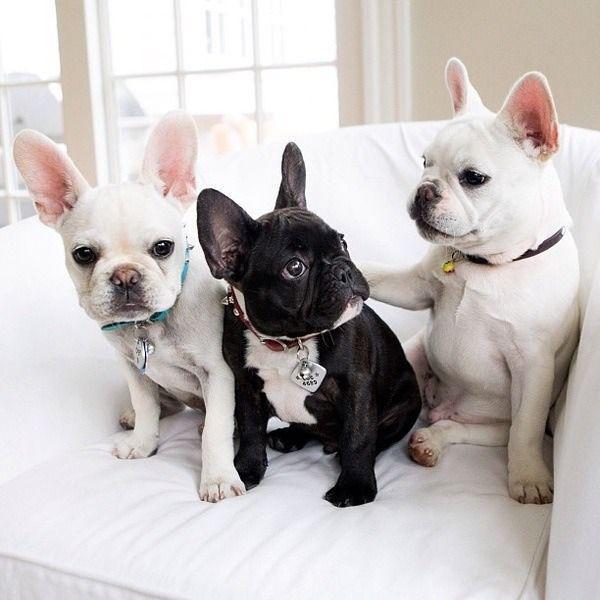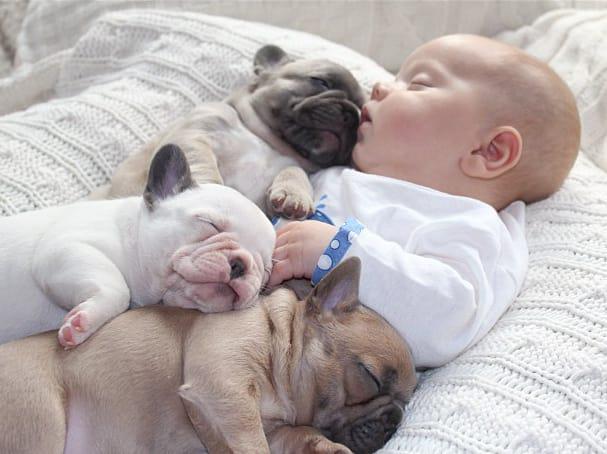The first image is the image on the left, the second image is the image on the right. Examine the images to the left and right. Is the description "Each image features one bulldog posed with something in front of its face, and the dog on the left is gnawing on something." accurate? Answer yes or no. No. The first image is the image on the left, the second image is the image on the right. Assess this claim about the two images: "One of the images features a dog chewing an object.". Correct or not? Answer yes or no. No. 